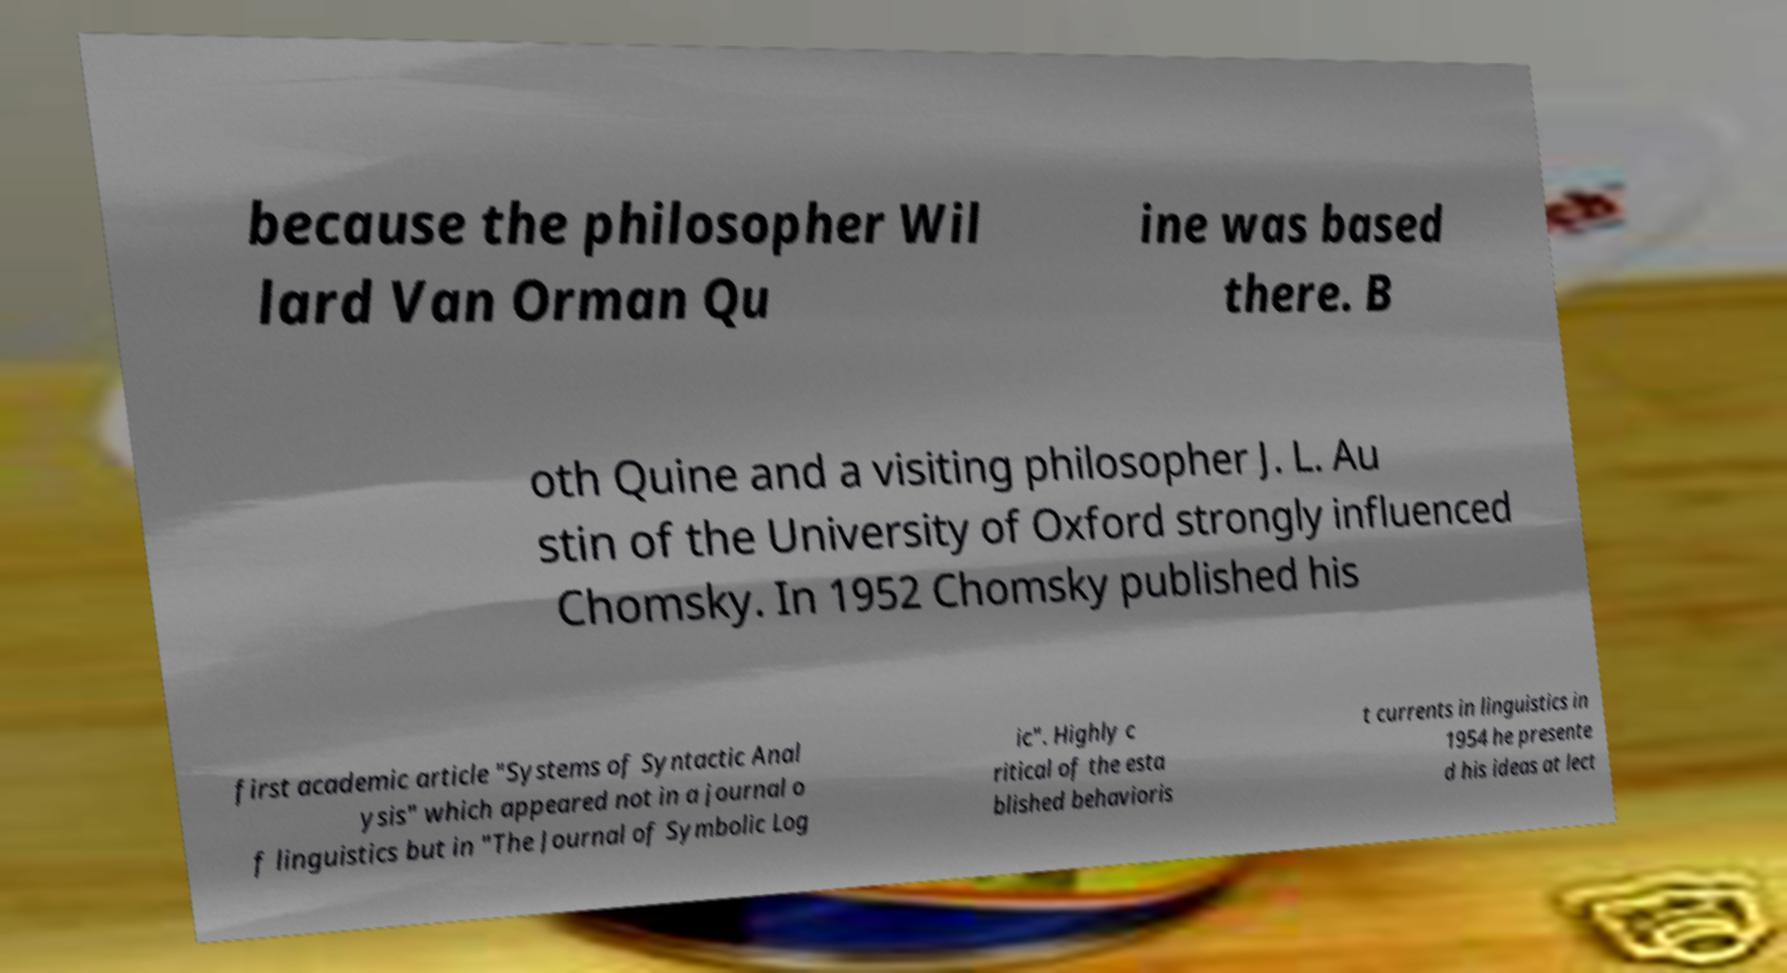Please read and relay the text visible in this image. What does it say? because the philosopher Wil lard Van Orman Qu ine was based there. B oth Quine and a visiting philosopher J. L. Au stin of the University of Oxford strongly influenced Chomsky. In 1952 Chomsky published his first academic article "Systems of Syntactic Anal ysis" which appeared not in a journal o f linguistics but in "The Journal of Symbolic Log ic". Highly c ritical of the esta blished behavioris t currents in linguistics in 1954 he presente d his ideas at lect 